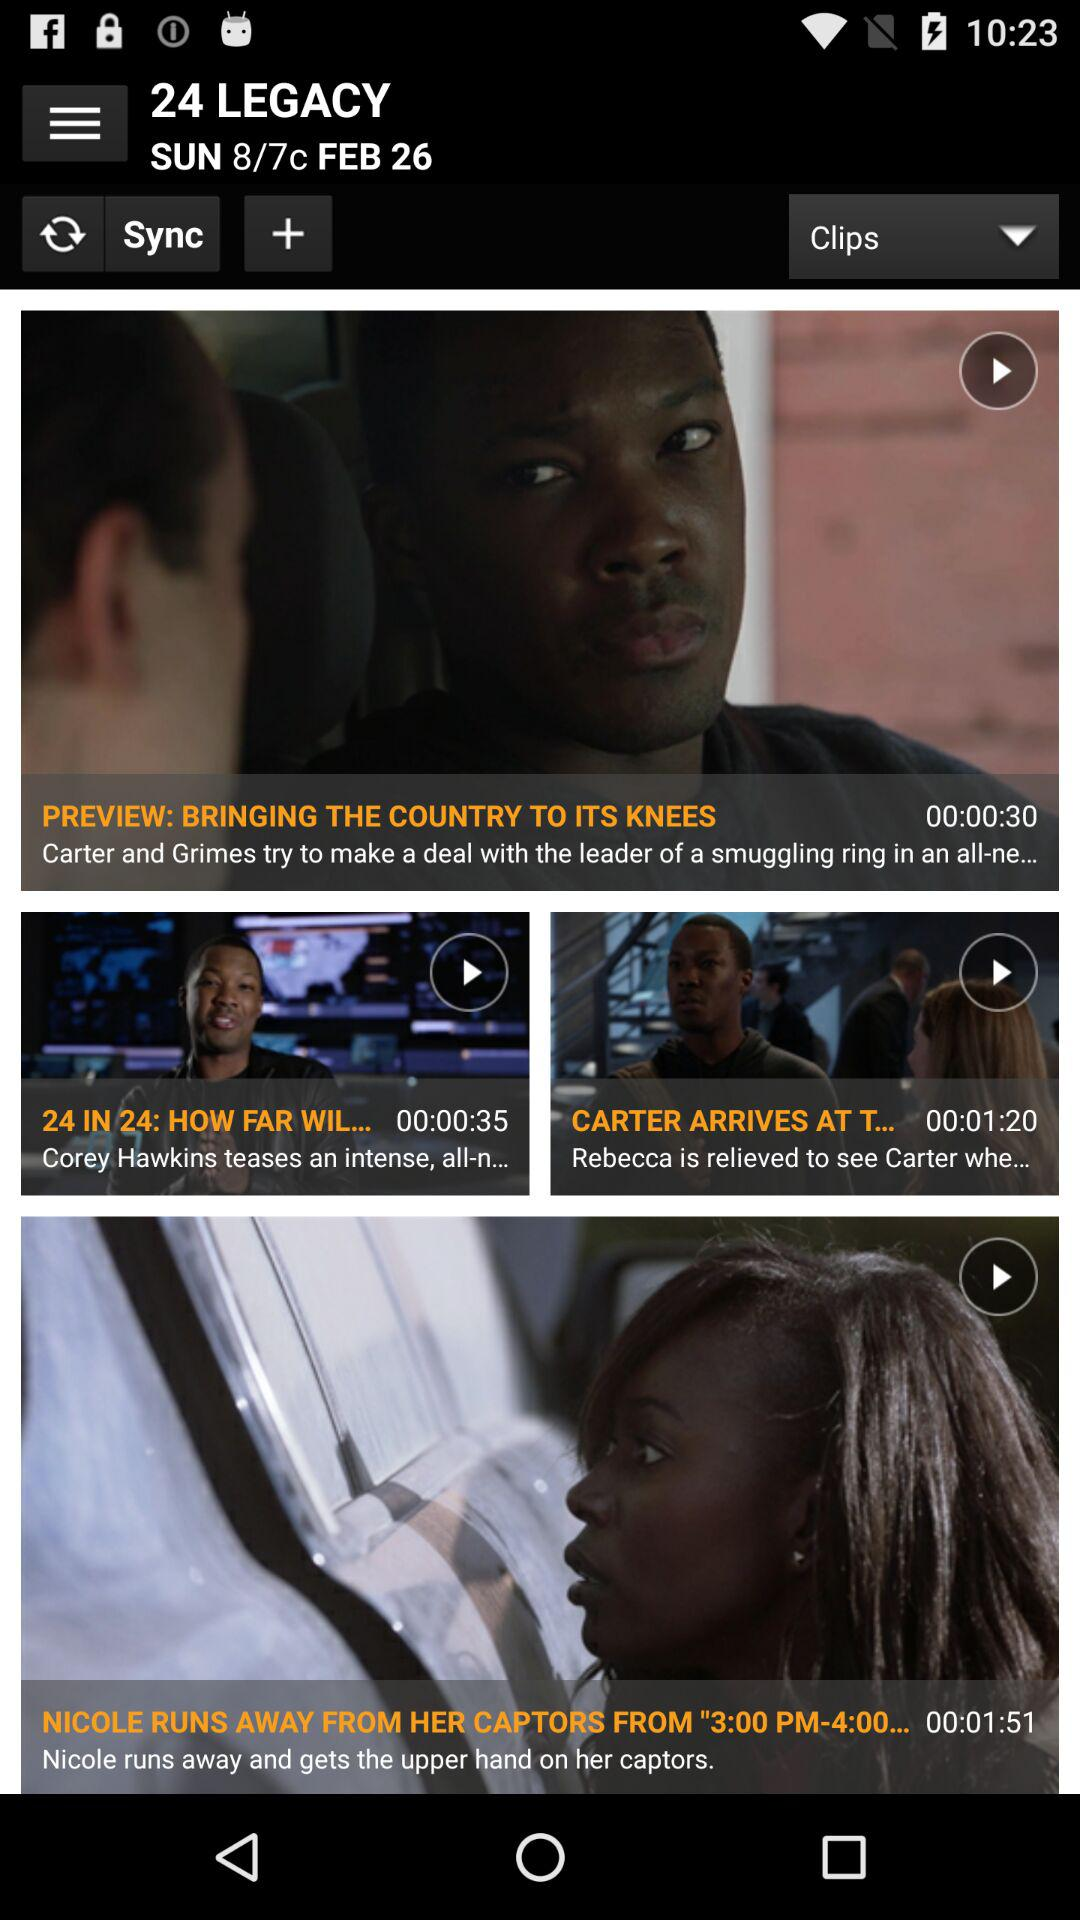What is the duration of "24 IN 24: HOW FAR WILL IT GO"? The duration is 35 seconds. 